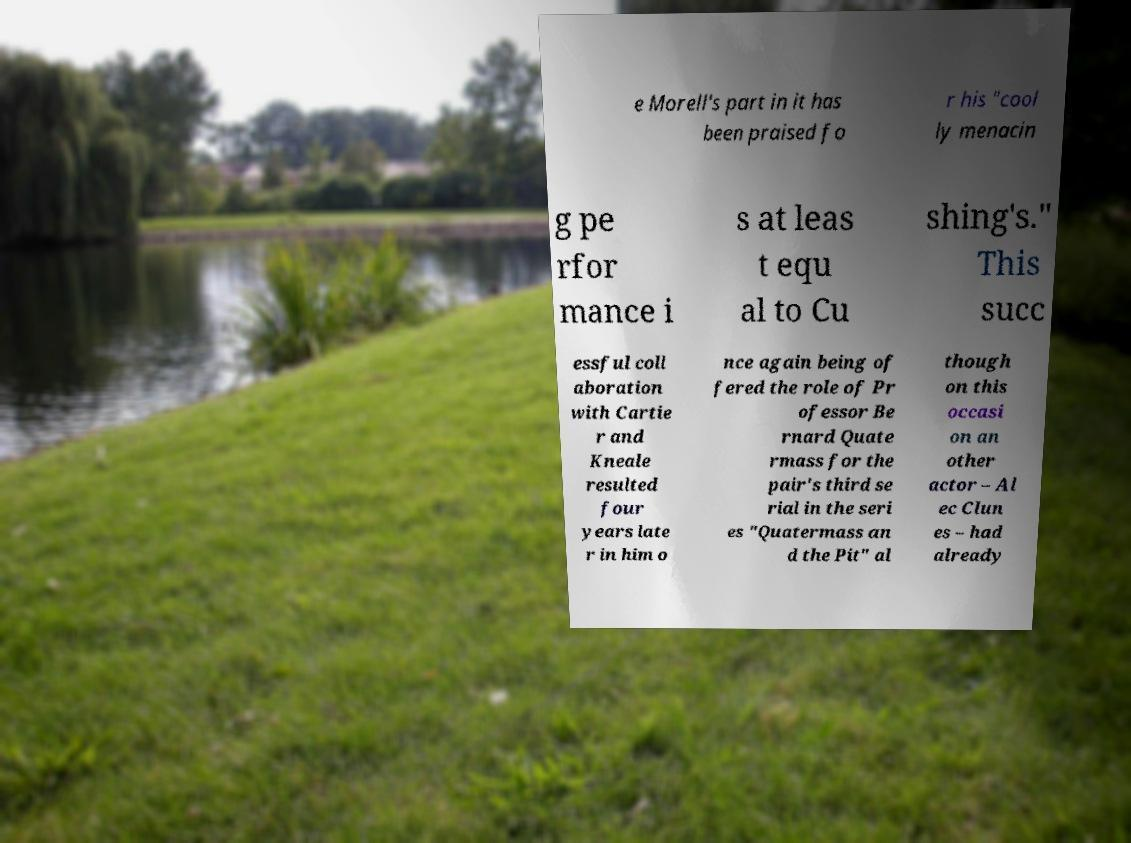I need the written content from this picture converted into text. Can you do that? e Morell's part in it has been praised fo r his "cool ly menacin g pe rfor mance i s at leas t equ al to Cu shing's." This succ essful coll aboration with Cartie r and Kneale resulted four years late r in him o nce again being of fered the role of Pr ofessor Be rnard Quate rmass for the pair's third se rial in the seri es "Quatermass an d the Pit" al though on this occasi on an other actor – Al ec Clun es – had already 